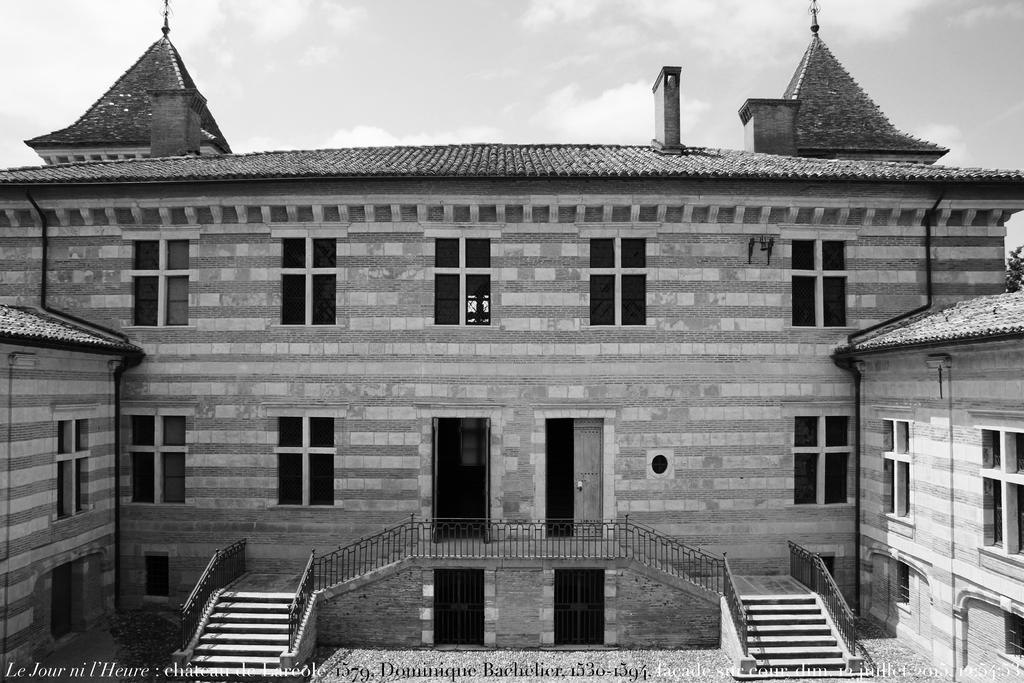What type of structure is present in the image? There is a building in the image. What architectural feature can be seen in the image? There are stairs in the image. What can be seen on the building in the image? There are windows in the image. What is visible in the background of the image? The sky is visible in the background of the image. How is the image presented in terms of color? The image is in black and white. What type of wood is used to construct the door in the image? There is no door present in the image, so it is not possible to determine the type of wood used for its construction. 